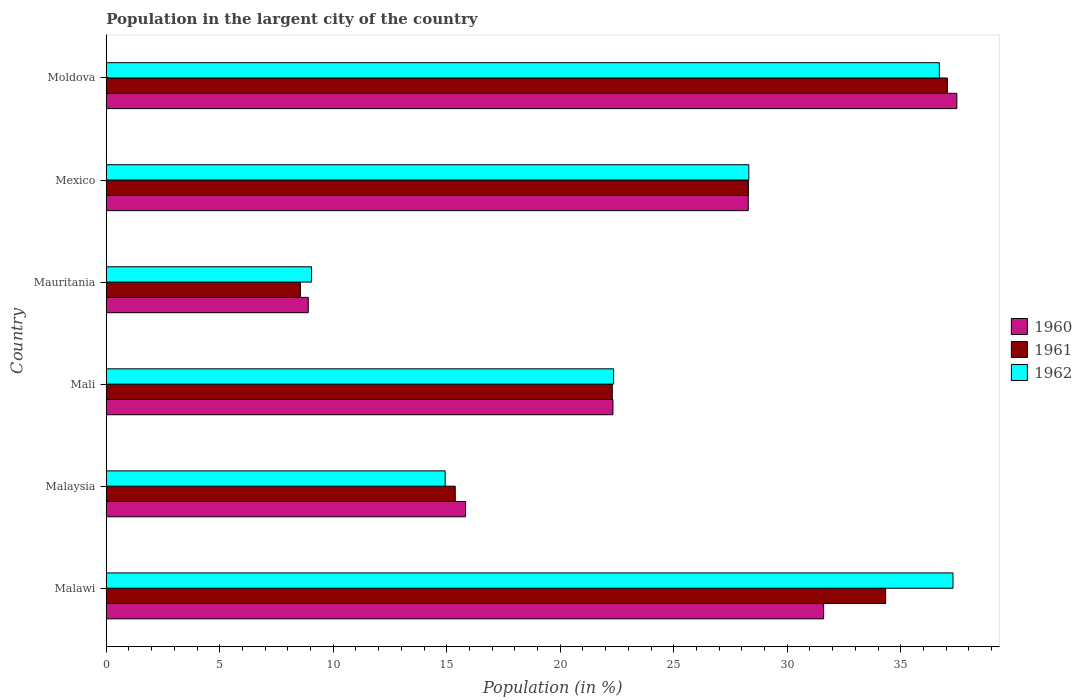How many different coloured bars are there?
Offer a very short reply. 3. How many groups of bars are there?
Offer a very short reply. 6. How many bars are there on the 1st tick from the top?
Make the answer very short. 3. What is the label of the 6th group of bars from the top?
Offer a very short reply. Malawi. What is the percentage of population in the largent city in 1962 in Mauritania?
Offer a very short reply. 9.04. Across all countries, what is the maximum percentage of population in the largent city in 1960?
Offer a terse response. 37.47. Across all countries, what is the minimum percentage of population in the largent city in 1962?
Your answer should be compact. 9.04. In which country was the percentage of population in the largent city in 1960 maximum?
Keep it short and to the point. Moldova. In which country was the percentage of population in the largent city in 1960 minimum?
Offer a terse response. Mauritania. What is the total percentage of population in the largent city in 1960 in the graph?
Offer a very short reply. 144.4. What is the difference between the percentage of population in the largent city in 1962 in Malawi and that in Malaysia?
Your response must be concise. 22.37. What is the difference between the percentage of population in the largent city in 1960 in Malawi and the percentage of population in the largent city in 1961 in Mexico?
Keep it short and to the point. 3.31. What is the average percentage of population in the largent city in 1962 per country?
Your answer should be very brief. 24.77. What is the difference between the percentage of population in the largent city in 1961 and percentage of population in the largent city in 1960 in Mexico?
Your answer should be compact. 0.01. In how many countries, is the percentage of population in the largent city in 1962 greater than 10 %?
Your answer should be compact. 5. What is the ratio of the percentage of population in the largent city in 1962 in Malaysia to that in Mali?
Make the answer very short. 0.67. Is the difference between the percentage of population in the largent city in 1961 in Mali and Mauritania greater than the difference between the percentage of population in the largent city in 1960 in Mali and Mauritania?
Provide a short and direct response. Yes. What is the difference between the highest and the second highest percentage of population in the largent city in 1961?
Provide a succinct answer. 2.72. What is the difference between the highest and the lowest percentage of population in the largent city in 1960?
Provide a short and direct response. 28.57. Is the sum of the percentage of population in the largent city in 1961 in Malawi and Mali greater than the maximum percentage of population in the largent city in 1960 across all countries?
Your answer should be compact. Yes. What does the 3rd bar from the top in Mauritania represents?
Ensure brevity in your answer.  1960. What does the 3rd bar from the bottom in Moldova represents?
Provide a short and direct response. 1962. Is it the case that in every country, the sum of the percentage of population in the largent city in 1962 and percentage of population in the largent city in 1961 is greater than the percentage of population in the largent city in 1960?
Provide a short and direct response. Yes. How many countries are there in the graph?
Your response must be concise. 6. Does the graph contain any zero values?
Offer a very short reply. No. What is the title of the graph?
Offer a terse response. Population in the largent city of the country. Does "2003" appear as one of the legend labels in the graph?
Offer a terse response. No. What is the label or title of the X-axis?
Offer a terse response. Population (in %). What is the label or title of the Y-axis?
Offer a very short reply. Country. What is the Population (in %) of 1960 in Malawi?
Give a very brief answer. 31.6. What is the Population (in %) in 1961 in Malawi?
Give a very brief answer. 34.33. What is the Population (in %) of 1962 in Malawi?
Keep it short and to the point. 37.3. What is the Population (in %) of 1960 in Malaysia?
Offer a terse response. 15.83. What is the Population (in %) of 1961 in Malaysia?
Your answer should be very brief. 15.37. What is the Population (in %) of 1962 in Malaysia?
Offer a terse response. 14.93. What is the Population (in %) of 1960 in Mali?
Your response must be concise. 22.32. What is the Population (in %) in 1961 in Mali?
Offer a very short reply. 22.29. What is the Population (in %) in 1962 in Mali?
Offer a very short reply. 22.35. What is the Population (in %) in 1960 in Mauritania?
Offer a terse response. 8.9. What is the Population (in %) of 1961 in Mauritania?
Offer a terse response. 8.55. What is the Population (in %) of 1962 in Mauritania?
Give a very brief answer. 9.04. What is the Population (in %) in 1960 in Mexico?
Keep it short and to the point. 28.28. What is the Population (in %) of 1961 in Mexico?
Provide a short and direct response. 28.29. What is the Population (in %) of 1962 in Mexico?
Make the answer very short. 28.31. What is the Population (in %) in 1960 in Moldova?
Give a very brief answer. 37.47. What is the Population (in %) in 1961 in Moldova?
Your answer should be compact. 37.05. What is the Population (in %) of 1962 in Moldova?
Offer a terse response. 36.7. Across all countries, what is the maximum Population (in %) of 1960?
Keep it short and to the point. 37.47. Across all countries, what is the maximum Population (in %) in 1961?
Offer a terse response. 37.05. Across all countries, what is the maximum Population (in %) in 1962?
Ensure brevity in your answer.  37.3. Across all countries, what is the minimum Population (in %) of 1960?
Provide a succinct answer. 8.9. Across all countries, what is the minimum Population (in %) of 1961?
Provide a short and direct response. 8.55. Across all countries, what is the minimum Population (in %) in 1962?
Offer a very short reply. 9.04. What is the total Population (in %) in 1960 in the graph?
Your answer should be compact. 144.4. What is the total Population (in %) in 1961 in the graph?
Keep it short and to the point. 145.89. What is the total Population (in %) of 1962 in the graph?
Your answer should be very brief. 148.63. What is the difference between the Population (in %) in 1960 in Malawi and that in Malaysia?
Provide a short and direct response. 15.77. What is the difference between the Population (in %) of 1961 in Malawi and that in Malaysia?
Provide a short and direct response. 18.96. What is the difference between the Population (in %) in 1962 in Malawi and that in Malaysia?
Your answer should be compact. 22.37. What is the difference between the Population (in %) of 1960 in Malawi and that in Mali?
Offer a very short reply. 9.28. What is the difference between the Population (in %) in 1961 in Malawi and that in Mali?
Your answer should be compact. 12.04. What is the difference between the Population (in %) of 1962 in Malawi and that in Mali?
Offer a very short reply. 14.95. What is the difference between the Population (in %) in 1960 in Malawi and that in Mauritania?
Keep it short and to the point. 22.7. What is the difference between the Population (in %) of 1961 in Malawi and that in Mauritania?
Your answer should be very brief. 25.78. What is the difference between the Population (in %) of 1962 in Malawi and that in Mauritania?
Give a very brief answer. 28.26. What is the difference between the Population (in %) in 1960 in Malawi and that in Mexico?
Offer a terse response. 3.32. What is the difference between the Population (in %) of 1961 in Malawi and that in Mexico?
Your answer should be compact. 6.05. What is the difference between the Population (in %) of 1962 in Malawi and that in Mexico?
Offer a very short reply. 8.99. What is the difference between the Population (in %) of 1960 in Malawi and that in Moldova?
Make the answer very short. -5.87. What is the difference between the Population (in %) in 1961 in Malawi and that in Moldova?
Your answer should be compact. -2.72. What is the difference between the Population (in %) of 1962 in Malawi and that in Moldova?
Make the answer very short. 0.6. What is the difference between the Population (in %) of 1960 in Malaysia and that in Mali?
Provide a succinct answer. -6.5. What is the difference between the Population (in %) of 1961 in Malaysia and that in Mali?
Provide a short and direct response. -6.92. What is the difference between the Population (in %) in 1962 in Malaysia and that in Mali?
Your answer should be compact. -7.42. What is the difference between the Population (in %) of 1960 in Malaysia and that in Mauritania?
Your answer should be compact. 6.93. What is the difference between the Population (in %) in 1961 in Malaysia and that in Mauritania?
Ensure brevity in your answer.  6.82. What is the difference between the Population (in %) of 1962 in Malaysia and that in Mauritania?
Your answer should be compact. 5.89. What is the difference between the Population (in %) of 1960 in Malaysia and that in Mexico?
Ensure brevity in your answer.  -12.45. What is the difference between the Population (in %) in 1961 in Malaysia and that in Mexico?
Keep it short and to the point. -12.91. What is the difference between the Population (in %) in 1962 in Malaysia and that in Mexico?
Provide a succinct answer. -13.38. What is the difference between the Population (in %) of 1960 in Malaysia and that in Moldova?
Keep it short and to the point. -21.64. What is the difference between the Population (in %) of 1961 in Malaysia and that in Moldova?
Keep it short and to the point. -21.68. What is the difference between the Population (in %) in 1962 in Malaysia and that in Moldova?
Your answer should be compact. -21.77. What is the difference between the Population (in %) of 1960 in Mali and that in Mauritania?
Your answer should be compact. 13.42. What is the difference between the Population (in %) of 1961 in Mali and that in Mauritania?
Your response must be concise. 13.74. What is the difference between the Population (in %) in 1962 in Mali and that in Mauritania?
Your response must be concise. 13.31. What is the difference between the Population (in %) in 1960 in Mali and that in Mexico?
Provide a short and direct response. -5.96. What is the difference between the Population (in %) in 1961 in Mali and that in Mexico?
Provide a short and direct response. -6. What is the difference between the Population (in %) in 1962 in Mali and that in Mexico?
Make the answer very short. -5.95. What is the difference between the Population (in %) in 1960 in Mali and that in Moldova?
Make the answer very short. -15.15. What is the difference between the Population (in %) of 1961 in Mali and that in Moldova?
Your response must be concise. -14.76. What is the difference between the Population (in %) of 1962 in Mali and that in Moldova?
Keep it short and to the point. -14.35. What is the difference between the Population (in %) of 1960 in Mauritania and that in Mexico?
Ensure brevity in your answer.  -19.38. What is the difference between the Population (in %) of 1961 in Mauritania and that in Mexico?
Your answer should be very brief. -19.73. What is the difference between the Population (in %) in 1962 in Mauritania and that in Mexico?
Your answer should be very brief. -19.26. What is the difference between the Population (in %) in 1960 in Mauritania and that in Moldova?
Ensure brevity in your answer.  -28.57. What is the difference between the Population (in %) in 1961 in Mauritania and that in Moldova?
Ensure brevity in your answer.  -28.5. What is the difference between the Population (in %) in 1962 in Mauritania and that in Moldova?
Offer a very short reply. -27.66. What is the difference between the Population (in %) of 1960 in Mexico and that in Moldova?
Keep it short and to the point. -9.19. What is the difference between the Population (in %) in 1961 in Mexico and that in Moldova?
Your response must be concise. -8.76. What is the difference between the Population (in %) of 1962 in Mexico and that in Moldova?
Your answer should be compact. -8.39. What is the difference between the Population (in %) of 1960 in Malawi and the Population (in %) of 1961 in Malaysia?
Keep it short and to the point. 16.23. What is the difference between the Population (in %) of 1960 in Malawi and the Population (in %) of 1962 in Malaysia?
Give a very brief answer. 16.67. What is the difference between the Population (in %) of 1961 in Malawi and the Population (in %) of 1962 in Malaysia?
Keep it short and to the point. 19.4. What is the difference between the Population (in %) in 1960 in Malawi and the Population (in %) in 1961 in Mali?
Your answer should be compact. 9.31. What is the difference between the Population (in %) in 1960 in Malawi and the Population (in %) in 1962 in Mali?
Your answer should be compact. 9.25. What is the difference between the Population (in %) in 1961 in Malawi and the Population (in %) in 1962 in Mali?
Provide a succinct answer. 11.98. What is the difference between the Population (in %) in 1960 in Malawi and the Population (in %) in 1961 in Mauritania?
Offer a terse response. 23.05. What is the difference between the Population (in %) of 1960 in Malawi and the Population (in %) of 1962 in Mauritania?
Provide a succinct answer. 22.56. What is the difference between the Population (in %) in 1961 in Malawi and the Population (in %) in 1962 in Mauritania?
Give a very brief answer. 25.29. What is the difference between the Population (in %) of 1960 in Malawi and the Population (in %) of 1961 in Mexico?
Make the answer very short. 3.31. What is the difference between the Population (in %) of 1960 in Malawi and the Population (in %) of 1962 in Mexico?
Provide a short and direct response. 3.29. What is the difference between the Population (in %) of 1961 in Malawi and the Population (in %) of 1962 in Mexico?
Make the answer very short. 6.03. What is the difference between the Population (in %) in 1960 in Malawi and the Population (in %) in 1961 in Moldova?
Offer a very short reply. -5.45. What is the difference between the Population (in %) in 1960 in Malawi and the Population (in %) in 1962 in Moldova?
Offer a terse response. -5.1. What is the difference between the Population (in %) of 1961 in Malawi and the Population (in %) of 1962 in Moldova?
Offer a terse response. -2.36. What is the difference between the Population (in %) of 1960 in Malaysia and the Population (in %) of 1961 in Mali?
Ensure brevity in your answer.  -6.46. What is the difference between the Population (in %) of 1960 in Malaysia and the Population (in %) of 1962 in Mali?
Your answer should be very brief. -6.52. What is the difference between the Population (in %) of 1961 in Malaysia and the Population (in %) of 1962 in Mali?
Offer a terse response. -6.98. What is the difference between the Population (in %) in 1960 in Malaysia and the Population (in %) in 1961 in Mauritania?
Provide a succinct answer. 7.27. What is the difference between the Population (in %) in 1960 in Malaysia and the Population (in %) in 1962 in Mauritania?
Your answer should be very brief. 6.78. What is the difference between the Population (in %) of 1961 in Malaysia and the Population (in %) of 1962 in Mauritania?
Ensure brevity in your answer.  6.33. What is the difference between the Population (in %) of 1960 in Malaysia and the Population (in %) of 1961 in Mexico?
Offer a very short reply. -12.46. What is the difference between the Population (in %) of 1960 in Malaysia and the Population (in %) of 1962 in Mexico?
Your answer should be compact. -12.48. What is the difference between the Population (in %) in 1961 in Malaysia and the Population (in %) in 1962 in Mexico?
Make the answer very short. -12.93. What is the difference between the Population (in %) of 1960 in Malaysia and the Population (in %) of 1961 in Moldova?
Your answer should be compact. -21.22. What is the difference between the Population (in %) of 1960 in Malaysia and the Population (in %) of 1962 in Moldova?
Offer a very short reply. -20.87. What is the difference between the Population (in %) of 1961 in Malaysia and the Population (in %) of 1962 in Moldova?
Make the answer very short. -21.32. What is the difference between the Population (in %) in 1960 in Mali and the Population (in %) in 1961 in Mauritania?
Ensure brevity in your answer.  13.77. What is the difference between the Population (in %) of 1960 in Mali and the Population (in %) of 1962 in Mauritania?
Your answer should be very brief. 13.28. What is the difference between the Population (in %) of 1961 in Mali and the Population (in %) of 1962 in Mauritania?
Offer a very short reply. 13.25. What is the difference between the Population (in %) in 1960 in Mali and the Population (in %) in 1961 in Mexico?
Offer a terse response. -5.97. What is the difference between the Population (in %) in 1960 in Mali and the Population (in %) in 1962 in Mexico?
Offer a very short reply. -5.98. What is the difference between the Population (in %) in 1961 in Mali and the Population (in %) in 1962 in Mexico?
Offer a terse response. -6.01. What is the difference between the Population (in %) of 1960 in Mali and the Population (in %) of 1961 in Moldova?
Keep it short and to the point. -14.73. What is the difference between the Population (in %) of 1960 in Mali and the Population (in %) of 1962 in Moldova?
Provide a short and direct response. -14.38. What is the difference between the Population (in %) of 1961 in Mali and the Population (in %) of 1962 in Moldova?
Provide a succinct answer. -14.41. What is the difference between the Population (in %) in 1960 in Mauritania and the Population (in %) in 1961 in Mexico?
Provide a succinct answer. -19.39. What is the difference between the Population (in %) in 1960 in Mauritania and the Population (in %) in 1962 in Mexico?
Offer a very short reply. -19.41. What is the difference between the Population (in %) of 1961 in Mauritania and the Population (in %) of 1962 in Mexico?
Your response must be concise. -19.75. What is the difference between the Population (in %) of 1960 in Mauritania and the Population (in %) of 1961 in Moldova?
Give a very brief answer. -28.15. What is the difference between the Population (in %) in 1960 in Mauritania and the Population (in %) in 1962 in Moldova?
Ensure brevity in your answer.  -27.8. What is the difference between the Population (in %) in 1961 in Mauritania and the Population (in %) in 1962 in Moldova?
Offer a terse response. -28.15. What is the difference between the Population (in %) of 1960 in Mexico and the Population (in %) of 1961 in Moldova?
Ensure brevity in your answer.  -8.77. What is the difference between the Population (in %) in 1960 in Mexico and the Population (in %) in 1962 in Moldova?
Your answer should be compact. -8.42. What is the difference between the Population (in %) in 1961 in Mexico and the Population (in %) in 1962 in Moldova?
Ensure brevity in your answer.  -8.41. What is the average Population (in %) of 1960 per country?
Offer a very short reply. 24.07. What is the average Population (in %) of 1961 per country?
Ensure brevity in your answer.  24.31. What is the average Population (in %) of 1962 per country?
Offer a terse response. 24.77. What is the difference between the Population (in %) in 1960 and Population (in %) in 1961 in Malawi?
Keep it short and to the point. -2.73. What is the difference between the Population (in %) in 1960 and Population (in %) in 1962 in Malawi?
Your response must be concise. -5.7. What is the difference between the Population (in %) in 1961 and Population (in %) in 1962 in Malawi?
Your answer should be very brief. -2.97. What is the difference between the Population (in %) in 1960 and Population (in %) in 1961 in Malaysia?
Make the answer very short. 0.45. What is the difference between the Population (in %) in 1960 and Population (in %) in 1962 in Malaysia?
Make the answer very short. 0.9. What is the difference between the Population (in %) of 1961 and Population (in %) of 1962 in Malaysia?
Your answer should be compact. 0.44. What is the difference between the Population (in %) in 1960 and Population (in %) in 1961 in Mali?
Give a very brief answer. 0.03. What is the difference between the Population (in %) in 1960 and Population (in %) in 1962 in Mali?
Your answer should be compact. -0.03. What is the difference between the Population (in %) of 1961 and Population (in %) of 1962 in Mali?
Provide a succinct answer. -0.06. What is the difference between the Population (in %) of 1960 and Population (in %) of 1961 in Mauritania?
Make the answer very short. 0.35. What is the difference between the Population (in %) in 1960 and Population (in %) in 1962 in Mauritania?
Provide a succinct answer. -0.14. What is the difference between the Population (in %) of 1961 and Population (in %) of 1962 in Mauritania?
Keep it short and to the point. -0.49. What is the difference between the Population (in %) of 1960 and Population (in %) of 1961 in Mexico?
Offer a very short reply. -0.01. What is the difference between the Population (in %) of 1960 and Population (in %) of 1962 in Mexico?
Offer a very short reply. -0.02. What is the difference between the Population (in %) in 1961 and Population (in %) in 1962 in Mexico?
Your answer should be very brief. -0.02. What is the difference between the Population (in %) in 1960 and Population (in %) in 1961 in Moldova?
Your response must be concise. 0.42. What is the difference between the Population (in %) of 1960 and Population (in %) of 1962 in Moldova?
Make the answer very short. 0.77. What is the difference between the Population (in %) of 1961 and Population (in %) of 1962 in Moldova?
Your response must be concise. 0.35. What is the ratio of the Population (in %) of 1960 in Malawi to that in Malaysia?
Offer a terse response. 2. What is the ratio of the Population (in %) in 1961 in Malawi to that in Malaysia?
Your response must be concise. 2.23. What is the ratio of the Population (in %) in 1962 in Malawi to that in Malaysia?
Your answer should be very brief. 2.5. What is the ratio of the Population (in %) in 1960 in Malawi to that in Mali?
Provide a succinct answer. 1.42. What is the ratio of the Population (in %) in 1961 in Malawi to that in Mali?
Your answer should be very brief. 1.54. What is the ratio of the Population (in %) in 1962 in Malawi to that in Mali?
Offer a terse response. 1.67. What is the ratio of the Population (in %) in 1960 in Malawi to that in Mauritania?
Provide a succinct answer. 3.55. What is the ratio of the Population (in %) in 1961 in Malawi to that in Mauritania?
Make the answer very short. 4.01. What is the ratio of the Population (in %) of 1962 in Malawi to that in Mauritania?
Provide a succinct answer. 4.12. What is the ratio of the Population (in %) of 1960 in Malawi to that in Mexico?
Your answer should be very brief. 1.12. What is the ratio of the Population (in %) of 1961 in Malawi to that in Mexico?
Give a very brief answer. 1.21. What is the ratio of the Population (in %) in 1962 in Malawi to that in Mexico?
Ensure brevity in your answer.  1.32. What is the ratio of the Population (in %) in 1960 in Malawi to that in Moldova?
Give a very brief answer. 0.84. What is the ratio of the Population (in %) of 1961 in Malawi to that in Moldova?
Keep it short and to the point. 0.93. What is the ratio of the Population (in %) in 1962 in Malawi to that in Moldova?
Your answer should be compact. 1.02. What is the ratio of the Population (in %) of 1960 in Malaysia to that in Mali?
Ensure brevity in your answer.  0.71. What is the ratio of the Population (in %) in 1961 in Malaysia to that in Mali?
Give a very brief answer. 0.69. What is the ratio of the Population (in %) in 1962 in Malaysia to that in Mali?
Your response must be concise. 0.67. What is the ratio of the Population (in %) in 1960 in Malaysia to that in Mauritania?
Provide a short and direct response. 1.78. What is the ratio of the Population (in %) of 1961 in Malaysia to that in Mauritania?
Provide a succinct answer. 1.8. What is the ratio of the Population (in %) in 1962 in Malaysia to that in Mauritania?
Your answer should be very brief. 1.65. What is the ratio of the Population (in %) of 1960 in Malaysia to that in Mexico?
Provide a short and direct response. 0.56. What is the ratio of the Population (in %) in 1961 in Malaysia to that in Mexico?
Your answer should be very brief. 0.54. What is the ratio of the Population (in %) in 1962 in Malaysia to that in Mexico?
Make the answer very short. 0.53. What is the ratio of the Population (in %) in 1960 in Malaysia to that in Moldova?
Give a very brief answer. 0.42. What is the ratio of the Population (in %) in 1961 in Malaysia to that in Moldova?
Provide a succinct answer. 0.41. What is the ratio of the Population (in %) in 1962 in Malaysia to that in Moldova?
Make the answer very short. 0.41. What is the ratio of the Population (in %) in 1960 in Mali to that in Mauritania?
Your response must be concise. 2.51. What is the ratio of the Population (in %) of 1961 in Mali to that in Mauritania?
Your answer should be very brief. 2.61. What is the ratio of the Population (in %) in 1962 in Mali to that in Mauritania?
Provide a succinct answer. 2.47. What is the ratio of the Population (in %) of 1960 in Mali to that in Mexico?
Give a very brief answer. 0.79. What is the ratio of the Population (in %) of 1961 in Mali to that in Mexico?
Ensure brevity in your answer.  0.79. What is the ratio of the Population (in %) of 1962 in Mali to that in Mexico?
Offer a very short reply. 0.79. What is the ratio of the Population (in %) of 1960 in Mali to that in Moldova?
Offer a terse response. 0.6. What is the ratio of the Population (in %) in 1961 in Mali to that in Moldova?
Make the answer very short. 0.6. What is the ratio of the Population (in %) of 1962 in Mali to that in Moldova?
Make the answer very short. 0.61. What is the ratio of the Population (in %) in 1960 in Mauritania to that in Mexico?
Provide a succinct answer. 0.31. What is the ratio of the Population (in %) in 1961 in Mauritania to that in Mexico?
Your answer should be very brief. 0.3. What is the ratio of the Population (in %) of 1962 in Mauritania to that in Mexico?
Offer a very short reply. 0.32. What is the ratio of the Population (in %) in 1960 in Mauritania to that in Moldova?
Your response must be concise. 0.24. What is the ratio of the Population (in %) in 1961 in Mauritania to that in Moldova?
Ensure brevity in your answer.  0.23. What is the ratio of the Population (in %) in 1962 in Mauritania to that in Moldova?
Offer a very short reply. 0.25. What is the ratio of the Population (in %) in 1960 in Mexico to that in Moldova?
Your answer should be compact. 0.75. What is the ratio of the Population (in %) in 1961 in Mexico to that in Moldova?
Offer a terse response. 0.76. What is the ratio of the Population (in %) in 1962 in Mexico to that in Moldova?
Offer a terse response. 0.77. What is the difference between the highest and the second highest Population (in %) in 1960?
Offer a terse response. 5.87. What is the difference between the highest and the second highest Population (in %) of 1961?
Provide a succinct answer. 2.72. What is the difference between the highest and the second highest Population (in %) in 1962?
Offer a terse response. 0.6. What is the difference between the highest and the lowest Population (in %) of 1960?
Provide a short and direct response. 28.57. What is the difference between the highest and the lowest Population (in %) of 1961?
Keep it short and to the point. 28.5. What is the difference between the highest and the lowest Population (in %) of 1962?
Make the answer very short. 28.26. 